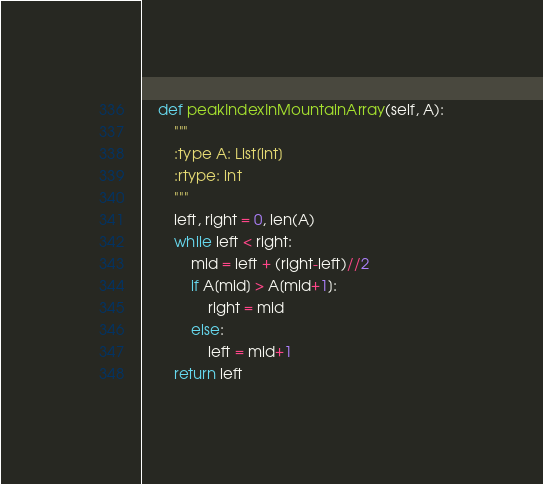Convert code to text. <code><loc_0><loc_0><loc_500><loc_500><_Python_>    def peakIndexInMountainArray(self, A):
        """
        :type A: List[int]
        :rtype: int
        """
        left, right = 0, len(A)
        while left < right:
            mid = left + (right-left)//2
            if A[mid] > A[mid+1]:
                right = mid
            else:
                left = mid+1
        return left
</code> 